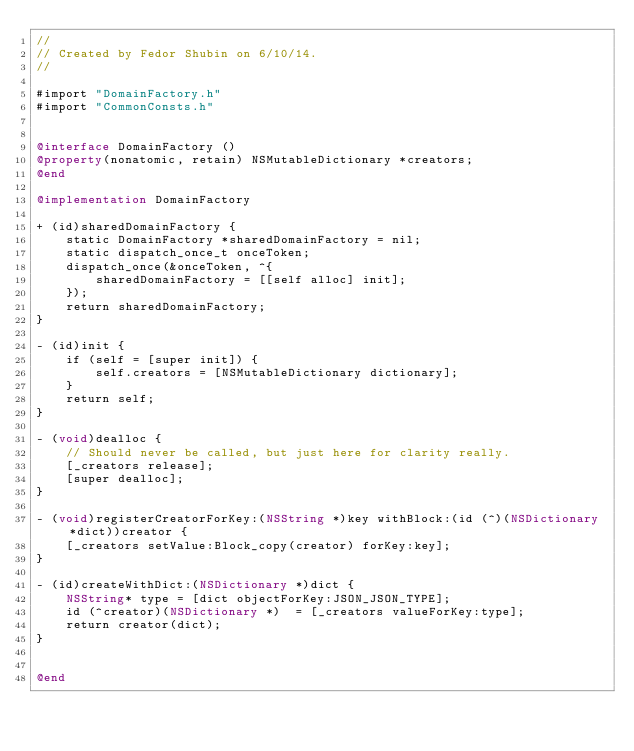<code> <loc_0><loc_0><loc_500><loc_500><_ObjectiveC_>//
// Created by Fedor Shubin on 6/10/14.
//

#import "DomainFactory.h"
#import "CommonConsts.h"


@interface DomainFactory ()
@property(nonatomic, retain) NSMutableDictionary *creators;
@end

@implementation DomainFactory

+ (id)sharedDomainFactory {
    static DomainFactory *sharedDomainFactory = nil;
    static dispatch_once_t onceToken;
    dispatch_once(&onceToken, ^{
        sharedDomainFactory = [[self alloc] init];
    });
    return sharedDomainFactory;
}

- (id)init {
    if (self = [super init]) {
        self.creators = [NSMutableDictionary dictionary];
    }
    return self;
}

- (void)dealloc {
    // Should never be called, but just here for clarity really.
    [_creators release];
    [super dealloc];
}

- (void)registerCreatorForKey:(NSString *)key withBlock:(id (^)(NSDictionary *dict))creator {
    [_creators setValue:Block_copy(creator) forKey:key];
}

- (id)createWithDict:(NSDictionary *)dict {
    NSString* type = [dict objectForKey:JSON_JSON_TYPE];
    id (^creator)(NSDictionary *)  = [_creators valueForKey:type];
    return creator(dict);
}


@end</code> 